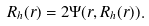Convert formula to latex. <formula><loc_0><loc_0><loc_500><loc_500>R _ { h } ( r ) = 2 \Psi ( r , R _ { h } ( r ) ) .</formula> 